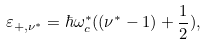Convert formula to latex. <formula><loc_0><loc_0><loc_500><loc_500>\varepsilon _ { + , \nu ^ { * } } = \hbar { \omega } _ { c } ^ { * } ( ( \nu ^ { * } - 1 ) + \frac { 1 } { 2 } ) ,</formula> 